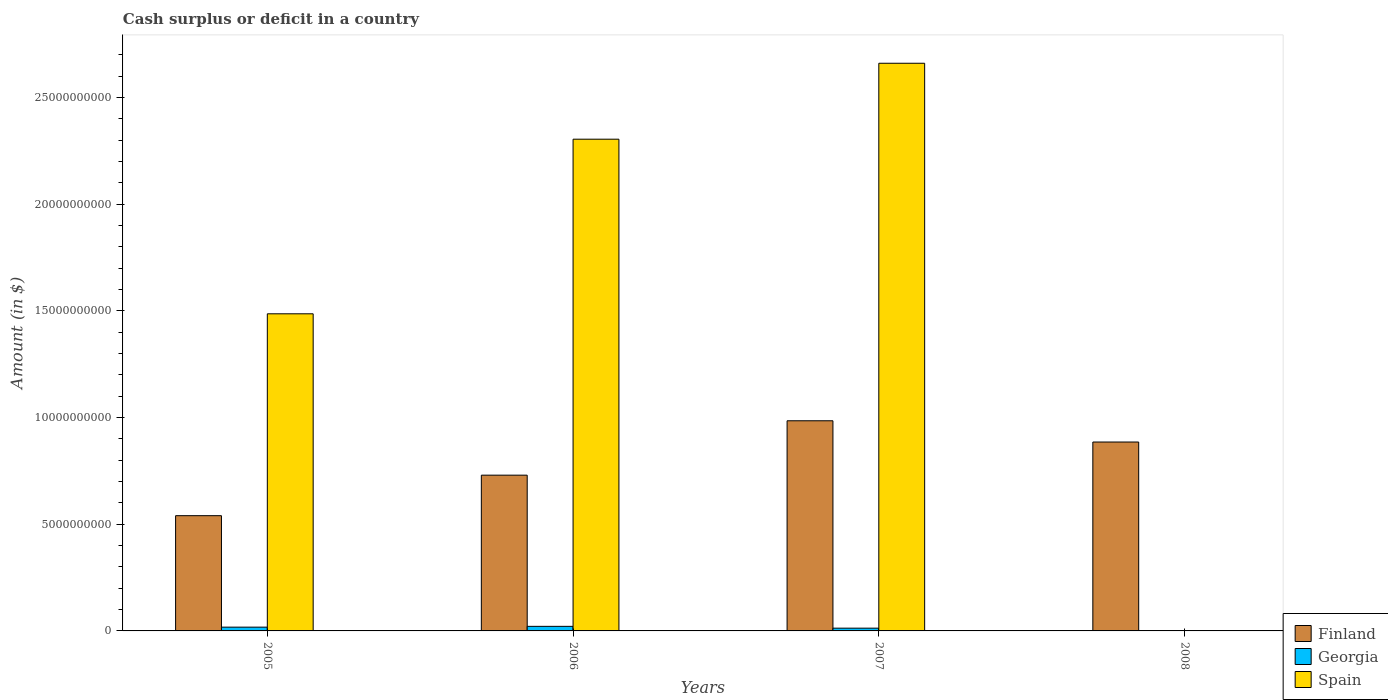What is the amount of cash surplus or deficit in Finland in 2007?
Your answer should be compact. 9.85e+09. Across all years, what is the maximum amount of cash surplus or deficit in Finland?
Ensure brevity in your answer.  9.85e+09. Across all years, what is the minimum amount of cash surplus or deficit in Finland?
Offer a very short reply. 5.40e+09. In which year was the amount of cash surplus or deficit in Finland maximum?
Your response must be concise. 2007. What is the total amount of cash surplus or deficit in Georgia in the graph?
Offer a very short reply. 5.21e+08. What is the difference between the amount of cash surplus or deficit in Georgia in 2005 and that in 2007?
Make the answer very short. 4.76e+07. What is the difference between the amount of cash surplus or deficit in Spain in 2007 and the amount of cash surplus or deficit in Georgia in 2005?
Your answer should be compact. 2.64e+1. What is the average amount of cash surplus or deficit in Finland per year?
Offer a very short reply. 7.85e+09. In the year 2007, what is the difference between the amount of cash surplus or deficit in Finland and amount of cash surplus or deficit in Georgia?
Offer a terse response. 9.72e+09. In how many years, is the amount of cash surplus or deficit in Finland greater than 18000000000 $?
Keep it short and to the point. 0. What is the ratio of the amount of cash surplus or deficit in Georgia in 2006 to that in 2007?
Give a very brief answer. 1.66. What is the difference between the highest and the second highest amount of cash surplus or deficit in Georgia?
Keep it short and to the point. 3.73e+07. What is the difference between the highest and the lowest amount of cash surplus or deficit in Spain?
Make the answer very short. 2.66e+1. In how many years, is the amount of cash surplus or deficit in Spain greater than the average amount of cash surplus or deficit in Spain taken over all years?
Your answer should be compact. 2. Is the sum of the amount of cash surplus or deficit in Finland in 2007 and 2008 greater than the maximum amount of cash surplus or deficit in Spain across all years?
Your response must be concise. No. How many bars are there?
Your answer should be very brief. 10. Does the graph contain grids?
Your answer should be very brief. No. Where does the legend appear in the graph?
Your answer should be compact. Bottom right. How many legend labels are there?
Offer a terse response. 3. How are the legend labels stacked?
Make the answer very short. Vertical. What is the title of the graph?
Your response must be concise. Cash surplus or deficit in a country. Does "Turkmenistan" appear as one of the legend labels in the graph?
Your response must be concise. No. What is the label or title of the Y-axis?
Ensure brevity in your answer.  Amount (in $). What is the Amount (in $) in Finland in 2005?
Provide a short and direct response. 5.40e+09. What is the Amount (in $) in Georgia in 2005?
Your answer should be compact. 1.77e+08. What is the Amount (in $) of Spain in 2005?
Offer a very short reply. 1.49e+1. What is the Amount (in $) in Finland in 2006?
Give a very brief answer. 7.30e+09. What is the Amount (in $) of Georgia in 2006?
Your answer should be compact. 2.14e+08. What is the Amount (in $) in Spain in 2006?
Offer a terse response. 2.30e+1. What is the Amount (in $) in Finland in 2007?
Give a very brief answer. 9.85e+09. What is the Amount (in $) of Georgia in 2007?
Provide a short and direct response. 1.30e+08. What is the Amount (in $) in Spain in 2007?
Provide a succinct answer. 2.66e+1. What is the Amount (in $) in Finland in 2008?
Offer a terse response. 8.86e+09. Across all years, what is the maximum Amount (in $) of Finland?
Provide a succinct answer. 9.85e+09. Across all years, what is the maximum Amount (in $) in Georgia?
Provide a short and direct response. 2.14e+08. Across all years, what is the maximum Amount (in $) of Spain?
Offer a very short reply. 2.66e+1. Across all years, what is the minimum Amount (in $) of Finland?
Provide a short and direct response. 5.40e+09. Across all years, what is the minimum Amount (in $) in Georgia?
Keep it short and to the point. 0. What is the total Amount (in $) of Finland in the graph?
Your answer should be very brief. 3.14e+1. What is the total Amount (in $) of Georgia in the graph?
Provide a succinct answer. 5.21e+08. What is the total Amount (in $) of Spain in the graph?
Offer a very short reply. 6.45e+1. What is the difference between the Amount (in $) of Finland in 2005 and that in 2006?
Ensure brevity in your answer.  -1.90e+09. What is the difference between the Amount (in $) in Georgia in 2005 and that in 2006?
Keep it short and to the point. -3.73e+07. What is the difference between the Amount (in $) in Spain in 2005 and that in 2006?
Offer a very short reply. -8.18e+09. What is the difference between the Amount (in $) in Finland in 2005 and that in 2007?
Your answer should be very brief. -4.45e+09. What is the difference between the Amount (in $) in Georgia in 2005 and that in 2007?
Keep it short and to the point. 4.76e+07. What is the difference between the Amount (in $) of Spain in 2005 and that in 2007?
Offer a very short reply. -1.17e+1. What is the difference between the Amount (in $) of Finland in 2005 and that in 2008?
Provide a succinct answer. -3.45e+09. What is the difference between the Amount (in $) in Finland in 2006 and that in 2007?
Keep it short and to the point. -2.55e+09. What is the difference between the Amount (in $) of Georgia in 2006 and that in 2007?
Provide a succinct answer. 8.49e+07. What is the difference between the Amount (in $) of Spain in 2006 and that in 2007?
Give a very brief answer. -3.56e+09. What is the difference between the Amount (in $) in Finland in 2006 and that in 2008?
Offer a very short reply. -1.55e+09. What is the difference between the Amount (in $) of Finland in 2007 and that in 2008?
Give a very brief answer. 9.96e+08. What is the difference between the Amount (in $) in Finland in 2005 and the Amount (in $) in Georgia in 2006?
Offer a very short reply. 5.19e+09. What is the difference between the Amount (in $) in Finland in 2005 and the Amount (in $) in Spain in 2006?
Your answer should be very brief. -1.76e+1. What is the difference between the Amount (in $) of Georgia in 2005 and the Amount (in $) of Spain in 2006?
Your response must be concise. -2.29e+1. What is the difference between the Amount (in $) in Finland in 2005 and the Amount (in $) in Georgia in 2007?
Keep it short and to the point. 5.27e+09. What is the difference between the Amount (in $) of Finland in 2005 and the Amount (in $) of Spain in 2007?
Ensure brevity in your answer.  -2.12e+1. What is the difference between the Amount (in $) of Georgia in 2005 and the Amount (in $) of Spain in 2007?
Offer a very short reply. -2.64e+1. What is the difference between the Amount (in $) of Finland in 2006 and the Amount (in $) of Georgia in 2007?
Your answer should be compact. 7.17e+09. What is the difference between the Amount (in $) in Finland in 2006 and the Amount (in $) in Spain in 2007?
Keep it short and to the point. -1.93e+1. What is the difference between the Amount (in $) of Georgia in 2006 and the Amount (in $) of Spain in 2007?
Make the answer very short. -2.64e+1. What is the average Amount (in $) of Finland per year?
Offer a very short reply. 7.85e+09. What is the average Amount (in $) of Georgia per year?
Make the answer very short. 1.30e+08. What is the average Amount (in $) of Spain per year?
Keep it short and to the point. 1.61e+1. In the year 2005, what is the difference between the Amount (in $) of Finland and Amount (in $) of Georgia?
Ensure brevity in your answer.  5.22e+09. In the year 2005, what is the difference between the Amount (in $) in Finland and Amount (in $) in Spain?
Offer a terse response. -9.46e+09. In the year 2005, what is the difference between the Amount (in $) of Georgia and Amount (in $) of Spain?
Offer a very short reply. -1.47e+1. In the year 2006, what is the difference between the Amount (in $) in Finland and Amount (in $) in Georgia?
Provide a succinct answer. 7.09e+09. In the year 2006, what is the difference between the Amount (in $) in Finland and Amount (in $) in Spain?
Keep it short and to the point. -1.57e+1. In the year 2006, what is the difference between the Amount (in $) of Georgia and Amount (in $) of Spain?
Ensure brevity in your answer.  -2.28e+1. In the year 2007, what is the difference between the Amount (in $) in Finland and Amount (in $) in Georgia?
Ensure brevity in your answer.  9.72e+09. In the year 2007, what is the difference between the Amount (in $) in Finland and Amount (in $) in Spain?
Provide a succinct answer. -1.68e+1. In the year 2007, what is the difference between the Amount (in $) of Georgia and Amount (in $) of Spain?
Provide a short and direct response. -2.65e+1. What is the ratio of the Amount (in $) in Finland in 2005 to that in 2006?
Keep it short and to the point. 0.74. What is the ratio of the Amount (in $) of Georgia in 2005 to that in 2006?
Your response must be concise. 0.83. What is the ratio of the Amount (in $) in Spain in 2005 to that in 2006?
Provide a short and direct response. 0.64. What is the ratio of the Amount (in $) of Finland in 2005 to that in 2007?
Make the answer very short. 0.55. What is the ratio of the Amount (in $) of Georgia in 2005 to that in 2007?
Give a very brief answer. 1.37. What is the ratio of the Amount (in $) in Spain in 2005 to that in 2007?
Ensure brevity in your answer.  0.56. What is the ratio of the Amount (in $) in Finland in 2005 to that in 2008?
Your answer should be compact. 0.61. What is the ratio of the Amount (in $) of Finland in 2006 to that in 2007?
Provide a succinct answer. 0.74. What is the ratio of the Amount (in $) of Georgia in 2006 to that in 2007?
Offer a terse response. 1.66. What is the ratio of the Amount (in $) of Spain in 2006 to that in 2007?
Your response must be concise. 0.87. What is the ratio of the Amount (in $) in Finland in 2006 to that in 2008?
Your answer should be very brief. 0.82. What is the ratio of the Amount (in $) in Finland in 2007 to that in 2008?
Ensure brevity in your answer.  1.11. What is the difference between the highest and the second highest Amount (in $) in Finland?
Your answer should be very brief. 9.96e+08. What is the difference between the highest and the second highest Amount (in $) of Georgia?
Give a very brief answer. 3.73e+07. What is the difference between the highest and the second highest Amount (in $) in Spain?
Provide a succinct answer. 3.56e+09. What is the difference between the highest and the lowest Amount (in $) in Finland?
Make the answer very short. 4.45e+09. What is the difference between the highest and the lowest Amount (in $) in Georgia?
Give a very brief answer. 2.14e+08. What is the difference between the highest and the lowest Amount (in $) of Spain?
Give a very brief answer. 2.66e+1. 